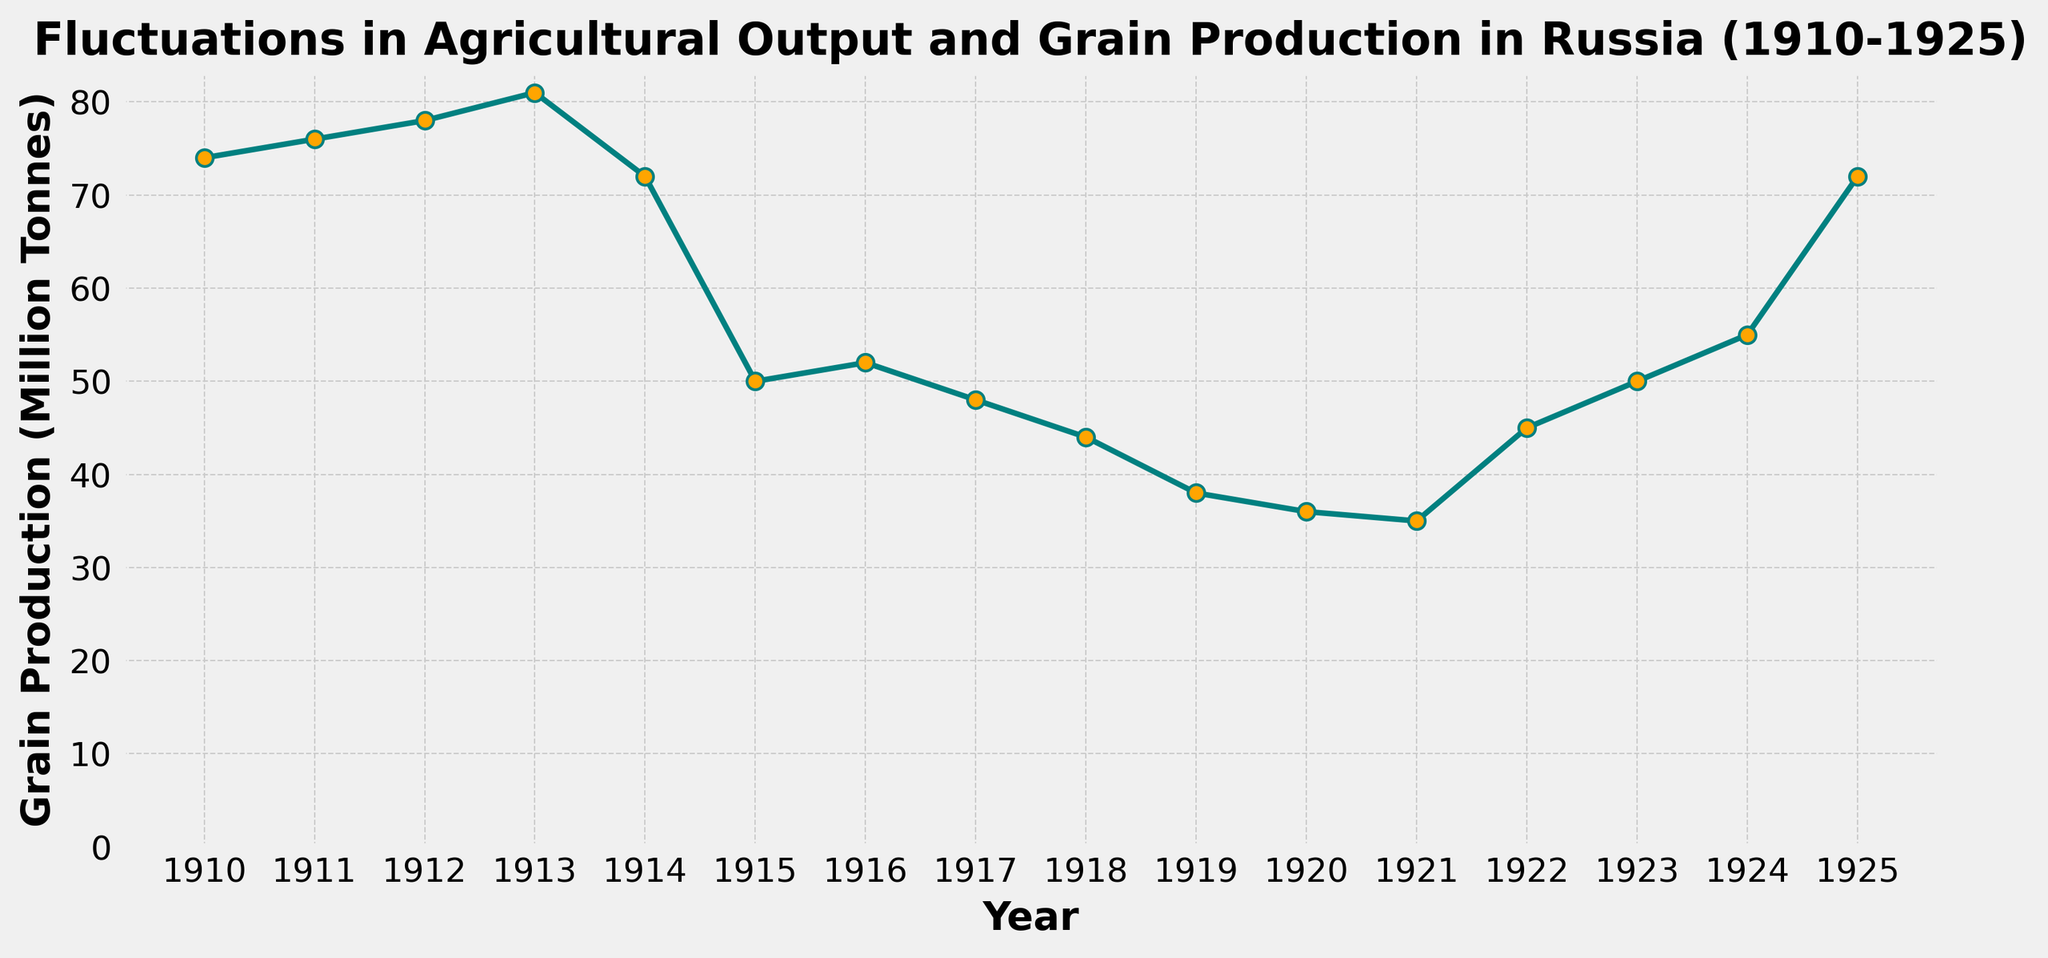What's the highest grain production recorded in the given period? Examine the line in the plot and look for the highest peak. The peak is at the year 1913 with a value of 81 million tonnes.
Answer: 81 million tonnes What is the difference in grain production between 1913 and 1921? Find the grain production values for 1913 (81 million tonnes) and 1921 (35 million tonnes). Subtract the 1921 value from the 1913 value, resulting in 81 - 35 = 46 million tonnes.
Answer: 46 million tonnes During which years did the grain production drop below 50 million tonnes? Check the data points on the plot for values lower than 50 million tonnes. These occur in the years 1917, 1918, 1919, 1920, and 1921.
Answer: 1917, 1918, 1919, 1920, 1921 What was the average grain production from 1914 to 1918? Find the grain production values for each year from 1914 to 1918: 72, 50, 52, 48, 44. Sum them up: 72 + 50 + 52 + 48 + 44 = 266. Divide by 5 (number of years) to get the average: 266/5 = 53.2 million tonnes.
Answer: 53.2 million tonnes In which year did grain production show the smallest increase or decrease compared to the previous year? Calculate the year-to-year changes: 1910-1911: +2, 1911-1912: +2, 1912-1913: +3, 1913-1914: -9, 1914-1915: -22, 1915-1916: +2, 1916-1917: -4, 1917-1918: -4, 1918-1919: -6, 1919-1920: -2, 1920-1921: -1, 1921-1922: +10, 1922-1923: +5, 1923-1924: +5, 1924-1925: +17. The smallest change is from 1920 to 1921 (change of -1).
Answer: 1921 How many years recorded a grain production value higher than 70 million tonnes? Examine the plot to identify the years where values exceed 70 million tonnes: 1910, 1911, 1912, 1913, and 1925. Count these years.
Answer: 5 years Between which consecutive years did the grain production experience the largest drop? Calculate the differences for each consecutive year. The largest drop is from 1914 to 1915 with a decrease of 22 million tonnes (72 - 50).
Answer: 1914 to 1915 Which year marks the first recorded production below 40 million tonnes? Check the plot for the first year where the grain production dips below 40 million tonnes. This occurs in 1919 with a value of 38 million tonnes.
Answer: 1919 What is the trend in grain production from 1919 to 1925? Observe the plot starting from 1919 (38 million tonnes) to 1925 (72 million tonnes). Notice a generally increasing trend over these years with some fluctuations.
Answer: Increasing trend 